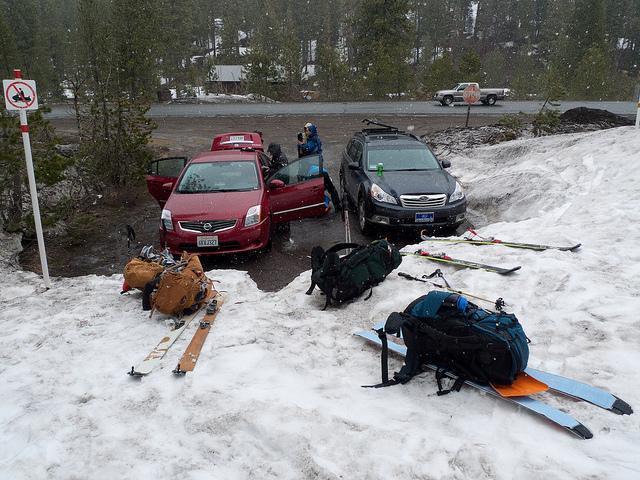What sort of outing are they embarking on?
Select the accurate answer and provide justification: `Answer: choice
Rationale: srationale.`
Options: Skiing, snowboarding, camping, beach. Answer: skiing.
Rationale: It is winter and each of them has a set of wooden planks that they will use to move through the snow. 